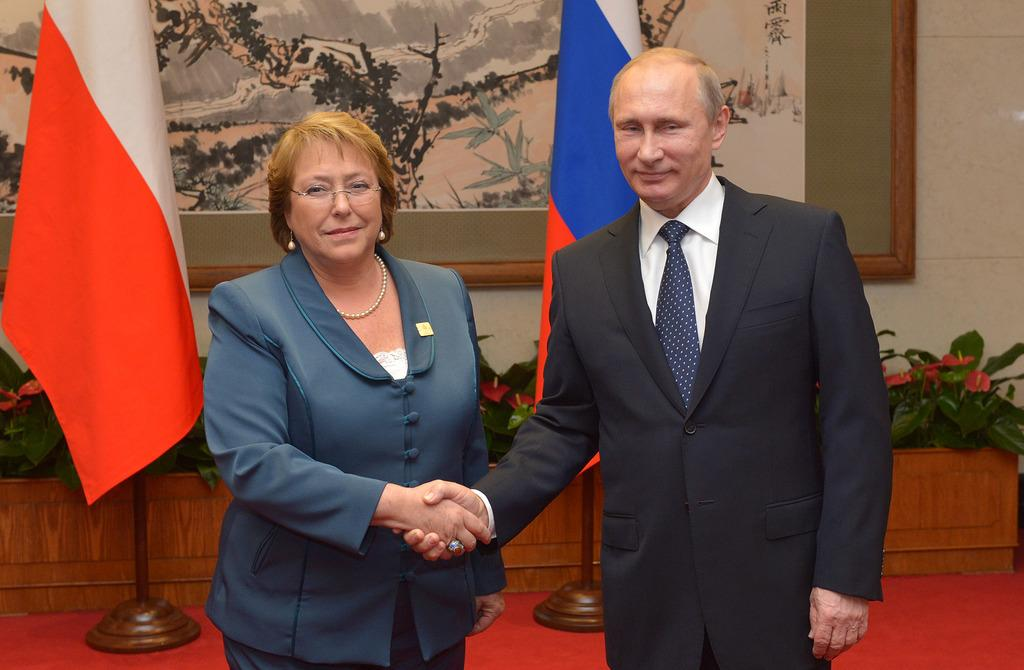Who are the people in the image? There is a man and a woman in the image. What are the man and woman doing in the image? The man and woman are shaking hands. What can be seen in the background of the image? There are flags visible in the background. What type of vegetation is present in the image? There are plants with flowers in the image. What is the frame on the back of the image used for? The frame on the back is used to display or protect the image. How many planes are flying in the image? There are no planes visible in the image. What type of show is the laborer performing in the image? There is no laborer or show present in the image. 